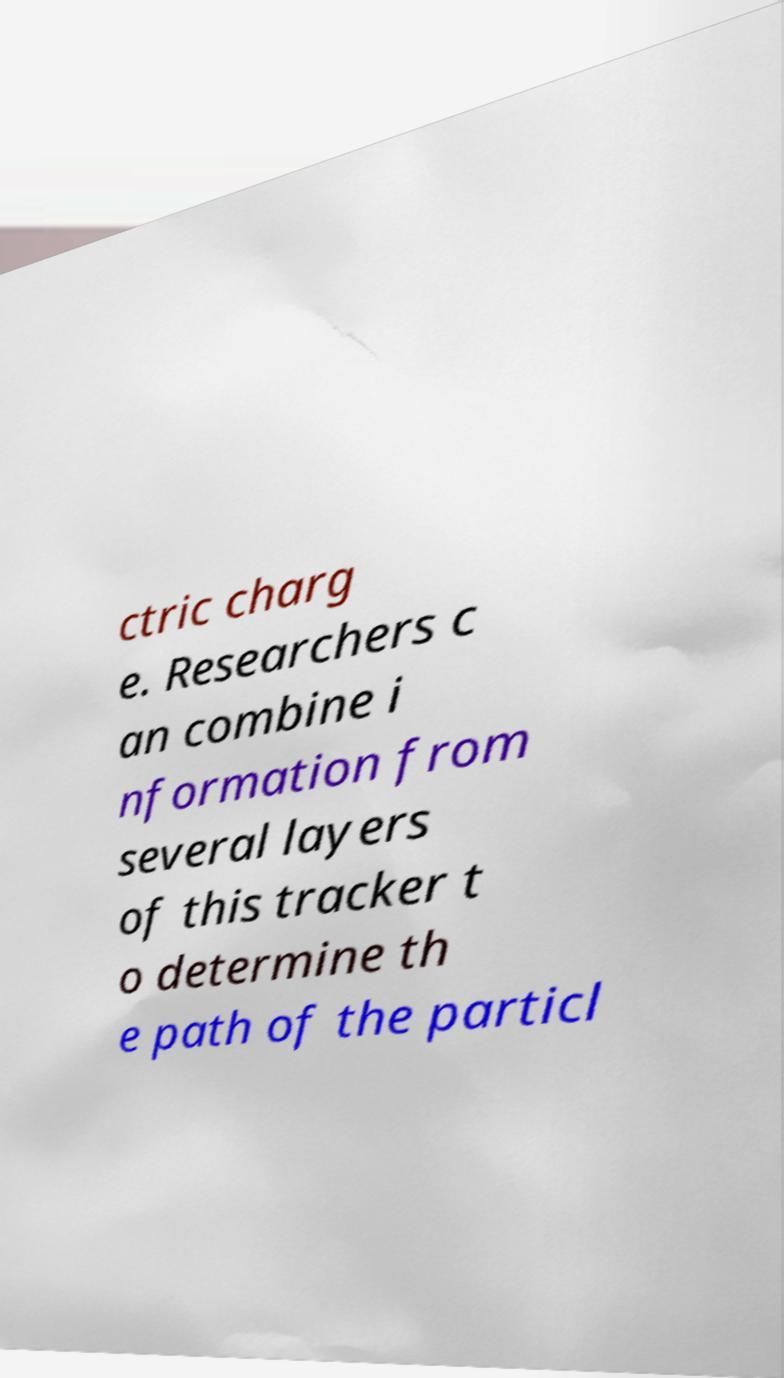What messages or text are displayed in this image? I need them in a readable, typed format. ctric charg e. Researchers c an combine i nformation from several layers of this tracker t o determine th e path of the particl 